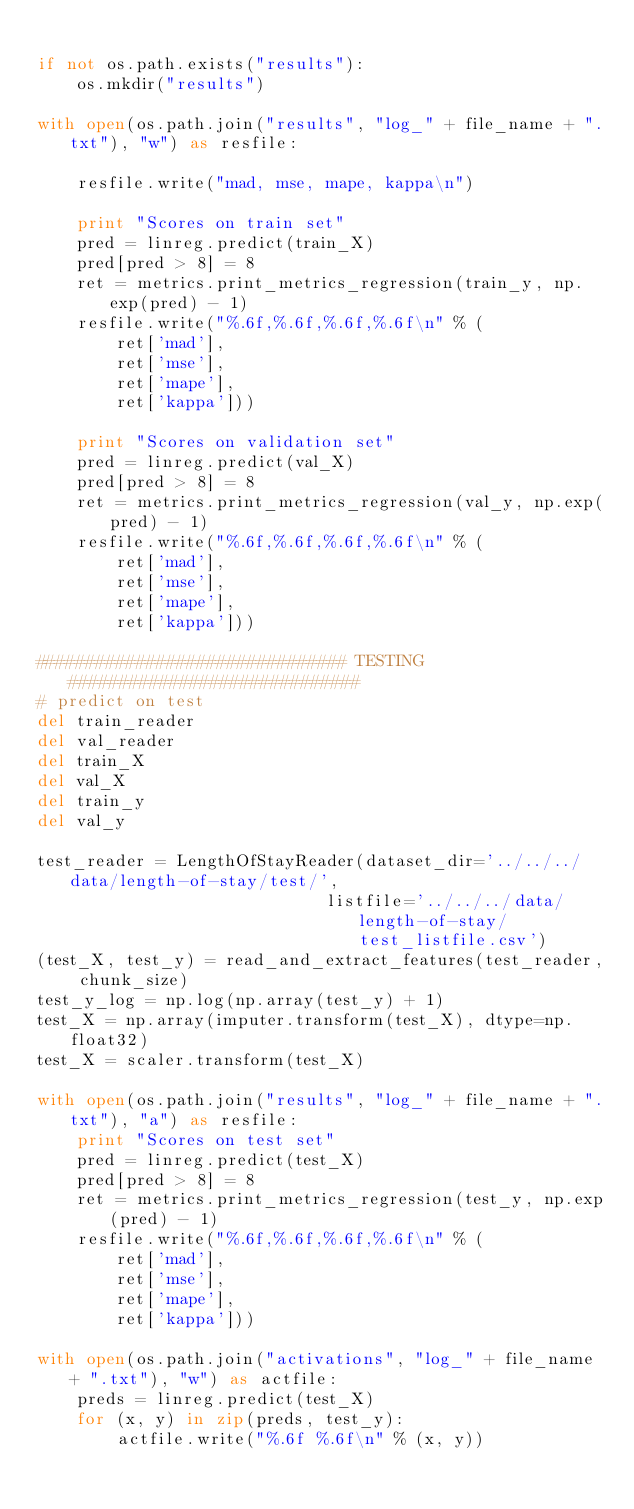Convert code to text. <code><loc_0><loc_0><loc_500><loc_500><_Python_>
if not os.path.exists("results"):
    os.mkdir("results")

with open(os.path.join("results", "log_" + file_name + ".txt"), "w") as resfile:

    resfile.write("mad, mse, mape, kappa\n")

    print "Scores on train set"
    pred = linreg.predict(train_X)
    pred[pred > 8] = 8
    ret = metrics.print_metrics_regression(train_y, np.exp(pred) - 1)
    resfile.write("%.6f,%.6f,%.6f,%.6f\n" % (
        ret['mad'],
        ret['mse'],
        ret['mape'],
        ret['kappa']))

    print "Scores on validation set"
    pred = linreg.predict(val_X)
    pred[pred > 8] = 8
    ret = metrics.print_metrics_regression(val_y, np.exp(pred) - 1)
    resfile.write("%.6f,%.6f,%.6f,%.6f\n" % (
        ret['mad'],
        ret['mse'],
        ret['mape'],
        ret['kappa']))

############################### TESTING #############################
# predict on test
del train_reader
del val_reader
del train_X
del val_X
del train_y
del val_y

test_reader = LengthOfStayReader(dataset_dir='../../../data/length-of-stay/test/',
                             listfile='../../../data/length-of-stay/test_listfile.csv')
(test_X, test_y) = read_and_extract_features(test_reader, chunk_size)
test_y_log = np.log(np.array(test_y) + 1)
test_X = np.array(imputer.transform(test_X), dtype=np.float32)
test_X = scaler.transform(test_X)

with open(os.path.join("results", "log_" + file_name + ".txt"), "a") as resfile:
    print "Scores on test set"
    pred = linreg.predict(test_X)
    pred[pred > 8] = 8
    ret = metrics.print_metrics_regression(test_y, np.exp(pred) - 1)
    resfile.write("%.6f,%.6f,%.6f,%.6f\n" % (
        ret['mad'],
        ret['mse'],
        ret['mape'],
        ret['kappa']))

with open(os.path.join("activations", "log_" + file_name + ".txt"), "w") as actfile:
    preds = linreg.predict(test_X)
    for (x, y) in zip(preds, test_y):
        actfile.write("%.6f %.6f\n" % (x, y))
</code> 